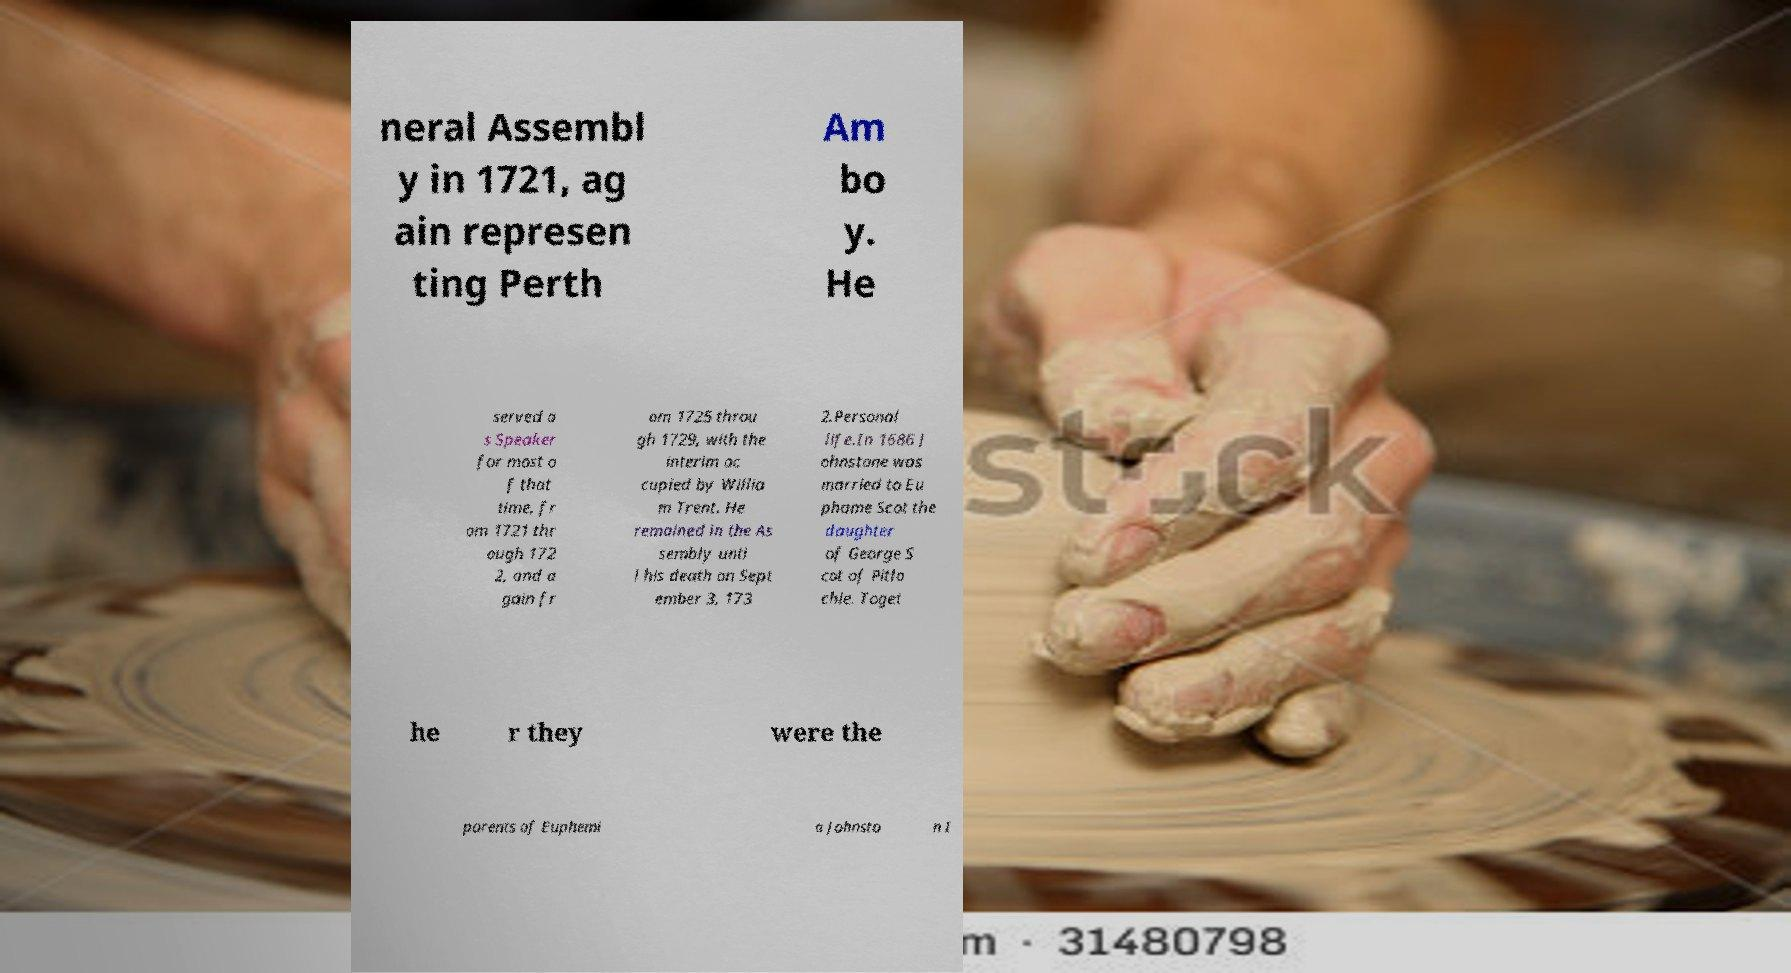There's text embedded in this image that I need extracted. Can you transcribe it verbatim? neral Assembl y in 1721, ag ain represen ting Perth Am bo y. He served a s Speaker for most o f that time, fr om 1721 thr ough 172 2, and a gain fr om 1725 throu gh 1729, with the interim oc cupied by Willia m Trent. He remained in the As sembly unti l his death on Sept ember 3, 173 2.Personal life.In 1686 J ohnstone was married to Eu phame Scot the daughter of George S cot of Pitlo chie. Toget he r they were the parents of Euphemi a Johnsto n I 